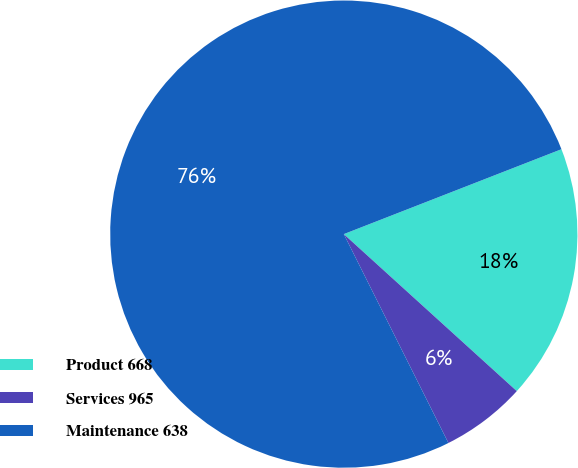Convert chart to OTSL. <chart><loc_0><loc_0><loc_500><loc_500><pie_chart><fcel>Product 668<fcel>Services 965<fcel>Maintenance 638<nl><fcel>17.65%<fcel>5.88%<fcel>76.47%<nl></chart> 